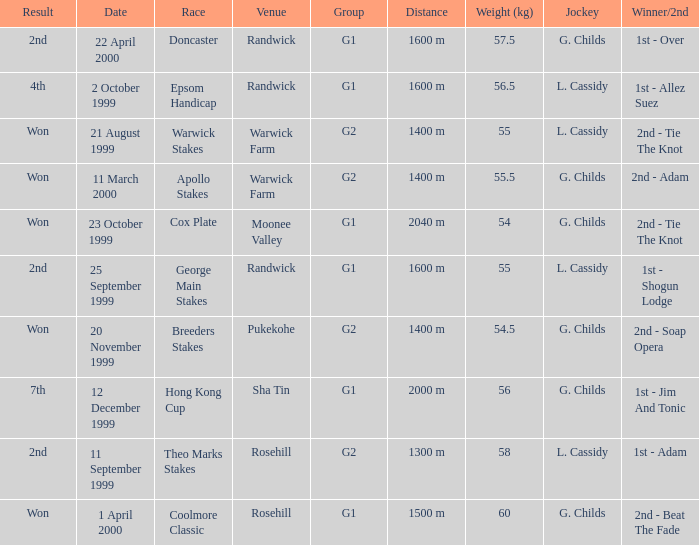How man teams had a total weight of 57.5? 1.0. 